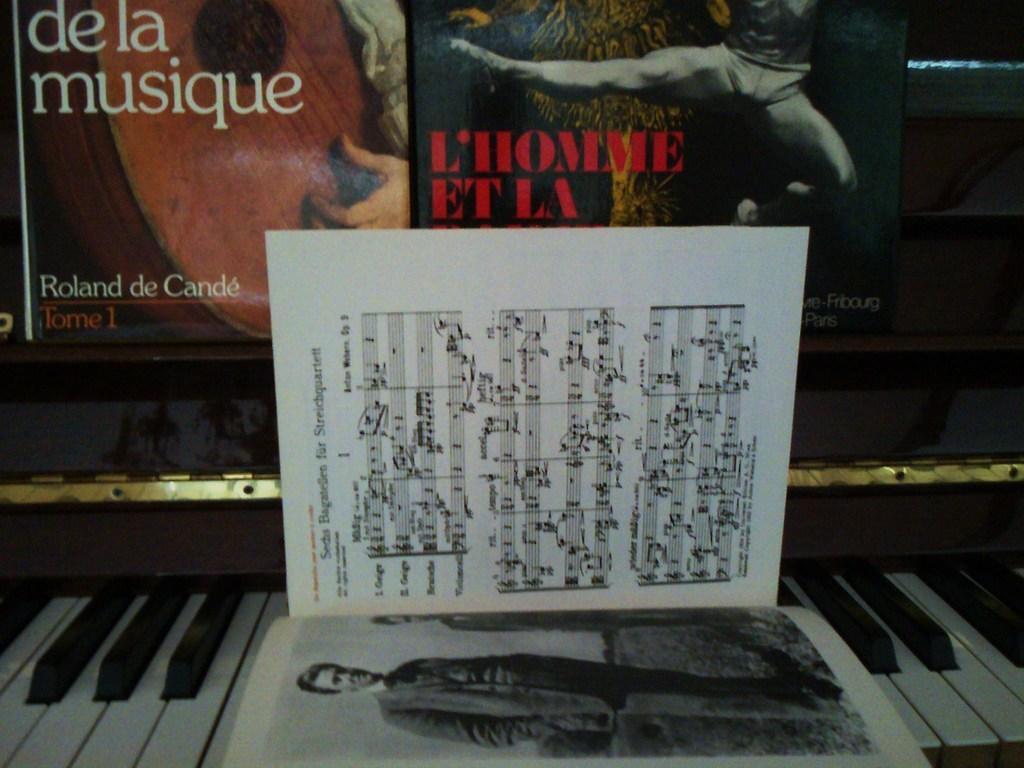Could you give a brief overview of what you see in this image? This picture shows piano and few posters on the wall and we see a book 